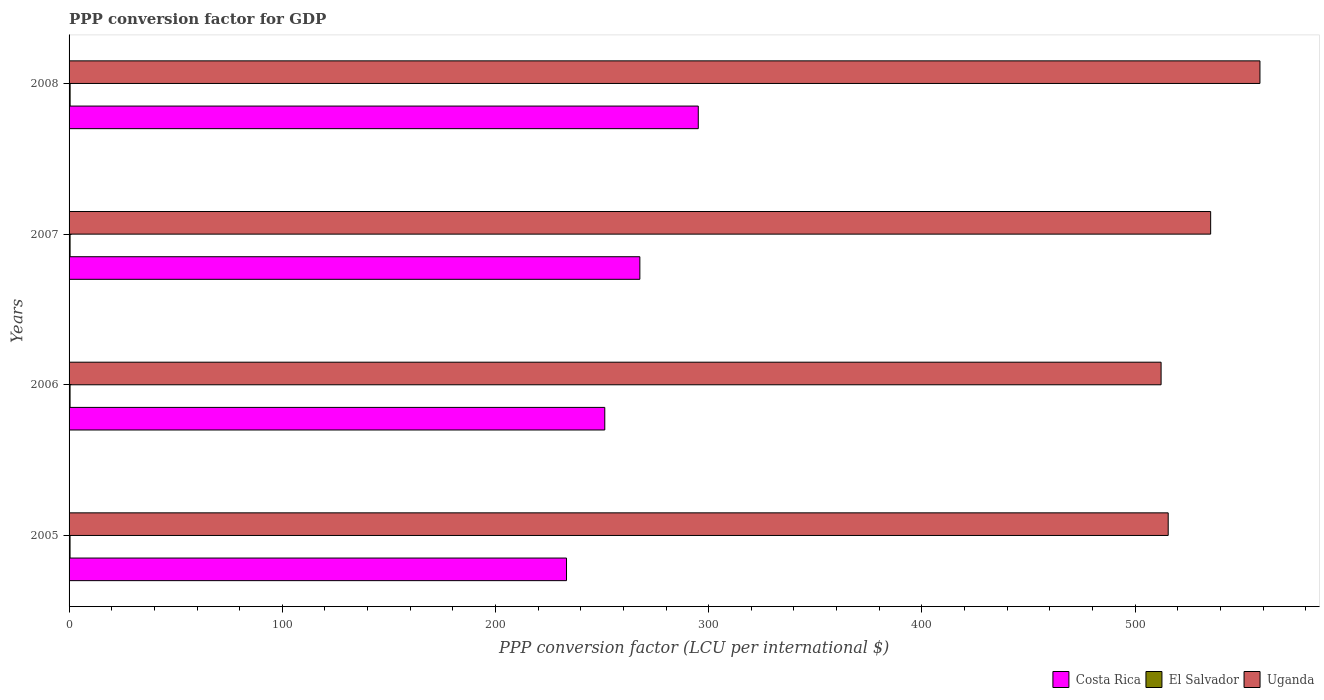How many different coloured bars are there?
Ensure brevity in your answer.  3. What is the label of the 3rd group of bars from the top?
Provide a short and direct response. 2006. What is the PPP conversion factor for GDP in Uganda in 2008?
Provide a succinct answer. 558.55. Across all years, what is the maximum PPP conversion factor for GDP in El Salvador?
Ensure brevity in your answer.  0.49. Across all years, what is the minimum PPP conversion factor for GDP in Uganda?
Make the answer very short. 512.18. In which year was the PPP conversion factor for GDP in Costa Rica maximum?
Offer a very short reply. 2008. What is the total PPP conversion factor for GDP in Costa Rica in the graph?
Ensure brevity in your answer.  1047.4. What is the difference between the PPP conversion factor for GDP in Costa Rica in 2007 and that in 2008?
Provide a succinct answer. -27.4. What is the difference between the PPP conversion factor for GDP in Uganda in 2006 and the PPP conversion factor for GDP in El Salvador in 2007?
Make the answer very short. 511.71. What is the average PPP conversion factor for GDP in Costa Rica per year?
Offer a very short reply. 261.85. In the year 2006, what is the difference between the PPP conversion factor for GDP in Costa Rica and PPP conversion factor for GDP in Uganda?
Make the answer very short. -260.92. What is the ratio of the PPP conversion factor for GDP in Uganda in 2007 to that in 2008?
Give a very brief answer. 0.96. Is the PPP conversion factor for GDP in El Salvador in 2005 less than that in 2006?
Your answer should be compact. Yes. What is the difference between the highest and the second highest PPP conversion factor for GDP in Uganda?
Your answer should be compact. 23.12. What is the difference between the highest and the lowest PPP conversion factor for GDP in Uganda?
Ensure brevity in your answer.  46.37. In how many years, is the PPP conversion factor for GDP in El Salvador greater than the average PPP conversion factor for GDP in El Salvador taken over all years?
Make the answer very short. 2. What does the 3rd bar from the top in 2005 represents?
Keep it short and to the point. Costa Rica. What does the 2nd bar from the bottom in 2007 represents?
Make the answer very short. El Salvador. How many bars are there?
Offer a very short reply. 12. Are all the bars in the graph horizontal?
Make the answer very short. Yes. What is the difference between two consecutive major ticks on the X-axis?
Provide a short and direct response. 100. Are the values on the major ticks of X-axis written in scientific E-notation?
Your answer should be compact. No. Does the graph contain any zero values?
Give a very brief answer. No. Does the graph contain grids?
Offer a terse response. No. How many legend labels are there?
Make the answer very short. 3. How are the legend labels stacked?
Offer a very short reply. Horizontal. What is the title of the graph?
Ensure brevity in your answer.  PPP conversion factor for GDP. What is the label or title of the X-axis?
Your answer should be very brief. PPP conversion factor (LCU per international $). What is the label or title of the Y-axis?
Your response must be concise. Years. What is the PPP conversion factor (LCU per international $) in Costa Rica in 2005?
Your answer should be compact. 233.31. What is the PPP conversion factor (LCU per international $) of El Salvador in 2005?
Offer a terse response. 0.46. What is the PPP conversion factor (LCU per international $) in Uganda in 2005?
Provide a short and direct response. 515.51. What is the PPP conversion factor (LCU per international $) in Costa Rica in 2006?
Your answer should be very brief. 251.26. What is the PPP conversion factor (LCU per international $) in El Salvador in 2006?
Offer a terse response. 0.46. What is the PPP conversion factor (LCU per international $) of Uganda in 2006?
Provide a succinct answer. 512.18. What is the PPP conversion factor (LCU per international $) of Costa Rica in 2007?
Your response must be concise. 267.71. What is the PPP conversion factor (LCU per international $) of El Salvador in 2007?
Give a very brief answer. 0.47. What is the PPP conversion factor (LCU per international $) in Uganda in 2007?
Give a very brief answer. 535.43. What is the PPP conversion factor (LCU per international $) of Costa Rica in 2008?
Your answer should be compact. 295.11. What is the PPP conversion factor (LCU per international $) in El Salvador in 2008?
Your response must be concise. 0.49. What is the PPP conversion factor (LCU per international $) in Uganda in 2008?
Provide a short and direct response. 558.55. Across all years, what is the maximum PPP conversion factor (LCU per international $) of Costa Rica?
Make the answer very short. 295.11. Across all years, what is the maximum PPP conversion factor (LCU per international $) in El Salvador?
Your answer should be compact. 0.49. Across all years, what is the maximum PPP conversion factor (LCU per international $) in Uganda?
Your response must be concise. 558.55. Across all years, what is the minimum PPP conversion factor (LCU per international $) of Costa Rica?
Keep it short and to the point. 233.31. Across all years, what is the minimum PPP conversion factor (LCU per international $) in El Salvador?
Your answer should be very brief. 0.46. Across all years, what is the minimum PPP conversion factor (LCU per international $) of Uganda?
Your answer should be very brief. 512.18. What is the total PPP conversion factor (LCU per international $) in Costa Rica in the graph?
Give a very brief answer. 1047.4. What is the total PPP conversion factor (LCU per international $) in El Salvador in the graph?
Your answer should be very brief. 1.88. What is the total PPP conversion factor (LCU per international $) of Uganda in the graph?
Offer a terse response. 2121.67. What is the difference between the PPP conversion factor (LCU per international $) of Costa Rica in 2005 and that in 2006?
Your answer should be compact. -17.94. What is the difference between the PPP conversion factor (LCU per international $) in El Salvador in 2005 and that in 2006?
Make the answer very short. -0.01. What is the difference between the PPP conversion factor (LCU per international $) in Uganda in 2005 and that in 2006?
Make the answer very short. 3.33. What is the difference between the PPP conversion factor (LCU per international $) of Costa Rica in 2005 and that in 2007?
Provide a short and direct response. -34.4. What is the difference between the PPP conversion factor (LCU per international $) in El Salvador in 2005 and that in 2007?
Your response must be concise. -0.01. What is the difference between the PPP conversion factor (LCU per international $) in Uganda in 2005 and that in 2007?
Provide a succinct answer. -19.91. What is the difference between the PPP conversion factor (LCU per international $) in Costa Rica in 2005 and that in 2008?
Your answer should be compact. -61.8. What is the difference between the PPP conversion factor (LCU per international $) of El Salvador in 2005 and that in 2008?
Give a very brief answer. -0.03. What is the difference between the PPP conversion factor (LCU per international $) in Uganda in 2005 and that in 2008?
Make the answer very short. -43.03. What is the difference between the PPP conversion factor (LCU per international $) in Costa Rica in 2006 and that in 2007?
Your answer should be very brief. -16.45. What is the difference between the PPP conversion factor (LCU per international $) of El Salvador in 2006 and that in 2007?
Your answer should be very brief. -0.01. What is the difference between the PPP conversion factor (LCU per international $) in Uganda in 2006 and that in 2007?
Keep it short and to the point. -23.25. What is the difference between the PPP conversion factor (LCU per international $) of Costa Rica in 2006 and that in 2008?
Give a very brief answer. -43.85. What is the difference between the PPP conversion factor (LCU per international $) in El Salvador in 2006 and that in 2008?
Ensure brevity in your answer.  -0.02. What is the difference between the PPP conversion factor (LCU per international $) of Uganda in 2006 and that in 2008?
Offer a terse response. -46.37. What is the difference between the PPP conversion factor (LCU per international $) in Costa Rica in 2007 and that in 2008?
Offer a terse response. -27.4. What is the difference between the PPP conversion factor (LCU per international $) of El Salvador in 2007 and that in 2008?
Keep it short and to the point. -0.02. What is the difference between the PPP conversion factor (LCU per international $) of Uganda in 2007 and that in 2008?
Your response must be concise. -23.12. What is the difference between the PPP conversion factor (LCU per international $) of Costa Rica in 2005 and the PPP conversion factor (LCU per international $) of El Salvador in 2006?
Your answer should be compact. 232.85. What is the difference between the PPP conversion factor (LCU per international $) of Costa Rica in 2005 and the PPP conversion factor (LCU per international $) of Uganda in 2006?
Your answer should be very brief. -278.87. What is the difference between the PPP conversion factor (LCU per international $) in El Salvador in 2005 and the PPP conversion factor (LCU per international $) in Uganda in 2006?
Your answer should be very brief. -511.72. What is the difference between the PPP conversion factor (LCU per international $) of Costa Rica in 2005 and the PPP conversion factor (LCU per international $) of El Salvador in 2007?
Keep it short and to the point. 232.84. What is the difference between the PPP conversion factor (LCU per international $) in Costa Rica in 2005 and the PPP conversion factor (LCU per international $) in Uganda in 2007?
Offer a terse response. -302.11. What is the difference between the PPP conversion factor (LCU per international $) of El Salvador in 2005 and the PPP conversion factor (LCU per international $) of Uganda in 2007?
Your answer should be very brief. -534.97. What is the difference between the PPP conversion factor (LCU per international $) of Costa Rica in 2005 and the PPP conversion factor (LCU per international $) of El Salvador in 2008?
Make the answer very short. 232.83. What is the difference between the PPP conversion factor (LCU per international $) in Costa Rica in 2005 and the PPP conversion factor (LCU per international $) in Uganda in 2008?
Ensure brevity in your answer.  -325.23. What is the difference between the PPP conversion factor (LCU per international $) of El Salvador in 2005 and the PPP conversion factor (LCU per international $) of Uganda in 2008?
Make the answer very short. -558.09. What is the difference between the PPP conversion factor (LCU per international $) of Costa Rica in 2006 and the PPP conversion factor (LCU per international $) of El Salvador in 2007?
Your answer should be compact. 250.79. What is the difference between the PPP conversion factor (LCU per international $) in Costa Rica in 2006 and the PPP conversion factor (LCU per international $) in Uganda in 2007?
Make the answer very short. -284.17. What is the difference between the PPP conversion factor (LCU per international $) of El Salvador in 2006 and the PPP conversion factor (LCU per international $) of Uganda in 2007?
Your answer should be compact. -534.96. What is the difference between the PPP conversion factor (LCU per international $) of Costa Rica in 2006 and the PPP conversion factor (LCU per international $) of El Salvador in 2008?
Keep it short and to the point. 250.77. What is the difference between the PPP conversion factor (LCU per international $) in Costa Rica in 2006 and the PPP conversion factor (LCU per international $) in Uganda in 2008?
Make the answer very short. -307.29. What is the difference between the PPP conversion factor (LCU per international $) in El Salvador in 2006 and the PPP conversion factor (LCU per international $) in Uganda in 2008?
Your answer should be very brief. -558.08. What is the difference between the PPP conversion factor (LCU per international $) in Costa Rica in 2007 and the PPP conversion factor (LCU per international $) in El Salvador in 2008?
Offer a very short reply. 267.23. What is the difference between the PPP conversion factor (LCU per international $) in Costa Rica in 2007 and the PPP conversion factor (LCU per international $) in Uganda in 2008?
Your response must be concise. -290.84. What is the difference between the PPP conversion factor (LCU per international $) of El Salvador in 2007 and the PPP conversion factor (LCU per international $) of Uganda in 2008?
Provide a short and direct response. -558.08. What is the average PPP conversion factor (LCU per international $) in Costa Rica per year?
Ensure brevity in your answer.  261.85. What is the average PPP conversion factor (LCU per international $) in El Salvador per year?
Your response must be concise. 0.47. What is the average PPP conversion factor (LCU per international $) of Uganda per year?
Provide a succinct answer. 530.42. In the year 2005, what is the difference between the PPP conversion factor (LCU per international $) of Costa Rica and PPP conversion factor (LCU per international $) of El Salvador?
Your response must be concise. 232.86. In the year 2005, what is the difference between the PPP conversion factor (LCU per international $) in Costa Rica and PPP conversion factor (LCU per international $) in Uganda?
Offer a terse response. -282.2. In the year 2005, what is the difference between the PPP conversion factor (LCU per international $) of El Salvador and PPP conversion factor (LCU per international $) of Uganda?
Offer a terse response. -515.06. In the year 2006, what is the difference between the PPP conversion factor (LCU per international $) in Costa Rica and PPP conversion factor (LCU per international $) in El Salvador?
Give a very brief answer. 250.79. In the year 2006, what is the difference between the PPP conversion factor (LCU per international $) in Costa Rica and PPP conversion factor (LCU per international $) in Uganda?
Keep it short and to the point. -260.92. In the year 2006, what is the difference between the PPP conversion factor (LCU per international $) of El Salvador and PPP conversion factor (LCU per international $) of Uganda?
Provide a short and direct response. -511.72. In the year 2007, what is the difference between the PPP conversion factor (LCU per international $) of Costa Rica and PPP conversion factor (LCU per international $) of El Salvador?
Offer a very short reply. 267.24. In the year 2007, what is the difference between the PPP conversion factor (LCU per international $) in Costa Rica and PPP conversion factor (LCU per international $) in Uganda?
Your answer should be compact. -267.72. In the year 2007, what is the difference between the PPP conversion factor (LCU per international $) in El Salvador and PPP conversion factor (LCU per international $) in Uganda?
Make the answer very short. -534.96. In the year 2008, what is the difference between the PPP conversion factor (LCU per international $) of Costa Rica and PPP conversion factor (LCU per international $) of El Salvador?
Your answer should be very brief. 294.63. In the year 2008, what is the difference between the PPP conversion factor (LCU per international $) of Costa Rica and PPP conversion factor (LCU per international $) of Uganda?
Keep it short and to the point. -263.44. In the year 2008, what is the difference between the PPP conversion factor (LCU per international $) of El Salvador and PPP conversion factor (LCU per international $) of Uganda?
Provide a short and direct response. -558.06. What is the ratio of the PPP conversion factor (LCU per international $) in Costa Rica in 2005 to that in 2006?
Your answer should be very brief. 0.93. What is the ratio of the PPP conversion factor (LCU per international $) of El Salvador in 2005 to that in 2006?
Your answer should be compact. 0.99. What is the ratio of the PPP conversion factor (LCU per international $) in Costa Rica in 2005 to that in 2007?
Keep it short and to the point. 0.87. What is the ratio of the PPP conversion factor (LCU per international $) in El Salvador in 2005 to that in 2007?
Give a very brief answer. 0.97. What is the ratio of the PPP conversion factor (LCU per international $) in Uganda in 2005 to that in 2007?
Your answer should be very brief. 0.96. What is the ratio of the PPP conversion factor (LCU per international $) in Costa Rica in 2005 to that in 2008?
Your response must be concise. 0.79. What is the ratio of the PPP conversion factor (LCU per international $) in El Salvador in 2005 to that in 2008?
Offer a terse response. 0.94. What is the ratio of the PPP conversion factor (LCU per international $) in Uganda in 2005 to that in 2008?
Your answer should be compact. 0.92. What is the ratio of the PPP conversion factor (LCU per international $) in Costa Rica in 2006 to that in 2007?
Offer a very short reply. 0.94. What is the ratio of the PPP conversion factor (LCU per international $) in El Salvador in 2006 to that in 2007?
Ensure brevity in your answer.  0.98. What is the ratio of the PPP conversion factor (LCU per international $) in Uganda in 2006 to that in 2007?
Give a very brief answer. 0.96. What is the ratio of the PPP conversion factor (LCU per international $) of Costa Rica in 2006 to that in 2008?
Ensure brevity in your answer.  0.85. What is the ratio of the PPP conversion factor (LCU per international $) in El Salvador in 2006 to that in 2008?
Your response must be concise. 0.95. What is the ratio of the PPP conversion factor (LCU per international $) of Uganda in 2006 to that in 2008?
Offer a terse response. 0.92. What is the ratio of the PPP conversion factor (LCU per international $) of Costa Rica in 2007 to that in 2008?
Your response must be concise. 0.91. What is the ratio of the PPP conversion factor (LCU per international $) of El Salvador in 2007 to that in 2008?
Offer a terse response. 0.97. What is the ratio of the PPP conversion factor (LCU per international $) of Uganda in 2007 to that in 2008?
Ensure brevity in your answer.  0.96. What is the difference between the highest and the second highest PPP conversion factor (LCU per international $) in Costa Rica?
Keep it short and to the point. 27.4. What is the difference between the highest and the second highest PPP conversion factor (LCU per international $) of El Salvador?
Offer a terse response. 0.02. What is the difference between the highest and the second highest PPP conversion factor (LCU per international $) in Uganda?
Offer a very short reply. 23.12. What is the difference between the highest and the lowest PPP conversion factor (LCU per international $) of Costa Rica?
Offer a very short reply. 61.8. What is the difference between the highest and the lowest PPP conversion factor (LCU per international $) in El Salvador?
Make the answer very short. 0.03. What is the difference between the highest and the lowest PPP conversion factor (LCU per international $) of Uganda?
Ensure brevity in your answer.  46.37. 